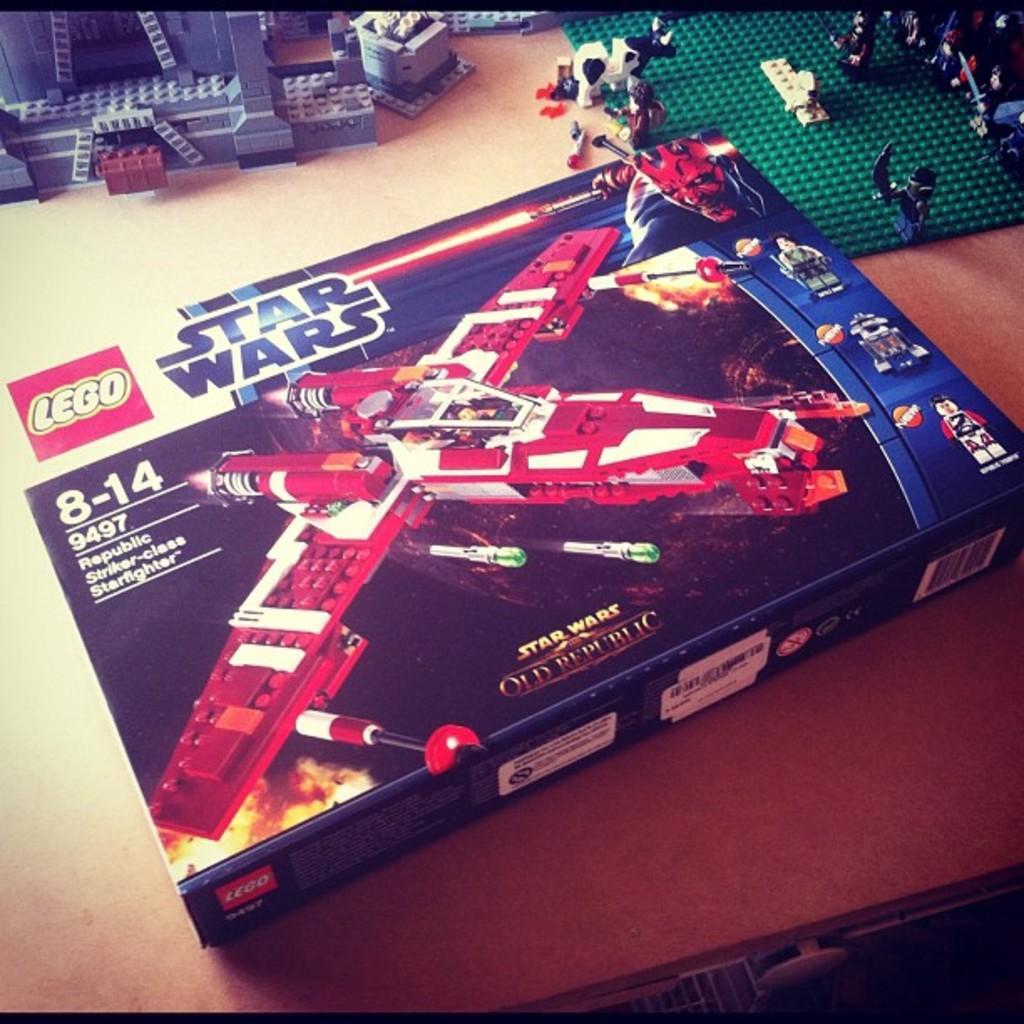How would you summarize this image in a sentence or two? In this picture i can see a toy box, toys and other objects on a table. On the box i can see pictures of toys. 